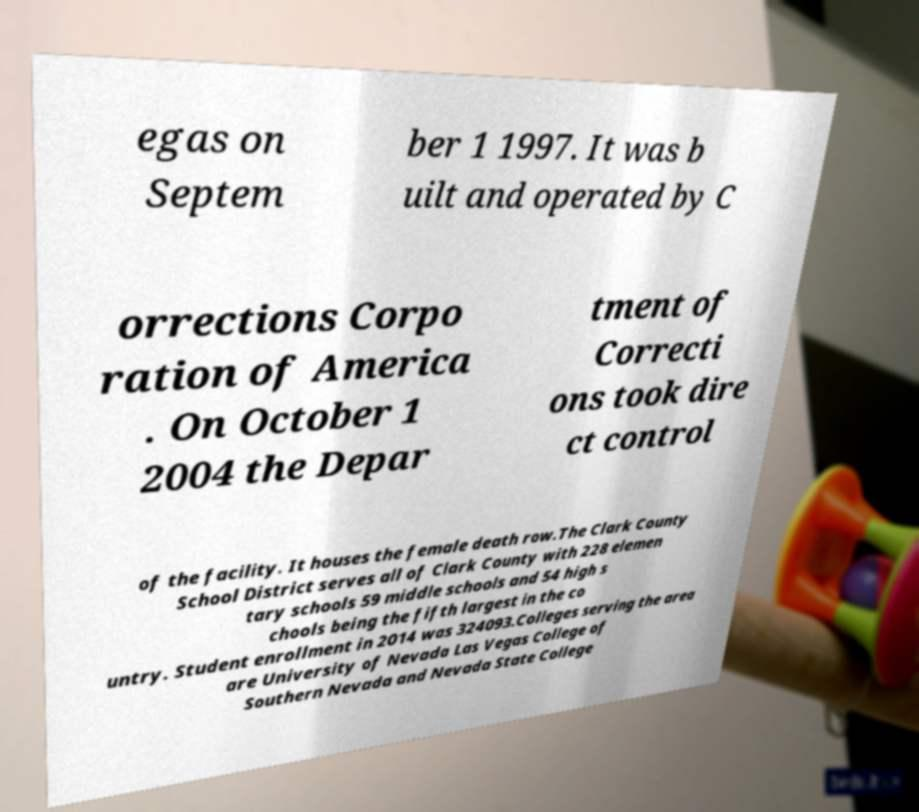Please read and relay the text visible in this image. What does it say? egas on Septem ber 1 1997. It was b uilt and operated by C orrections Corpo ration of America . On October 1 2004 the Depar tment of Correcti ons took dire ct control of the facility. It houses the female death row.The Clark County School District serves all of Clark County with 228 elemen tary schools 59 middle schools and 54 high s chools being the fifth largest in the co untry. Student enrollment in 2014 was 324093.Colleges serving the area are University of Nevada Las Vegas College of Southern Nevada and Nevada State College 